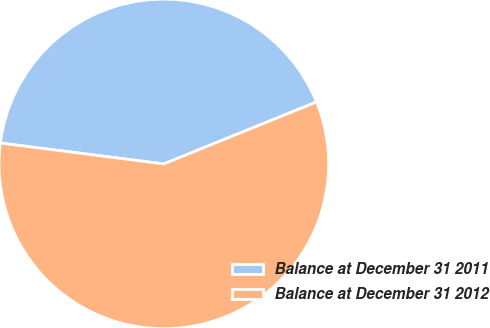Convert chart. <chart><loc_0><loc_0><loc_500><loc_500><pie_chart><fcel>Balance at December 31 2011<fcel>Balance at December 31 2012<nl><fcel>41.84%<fcel>58.16%<nl></chart> 